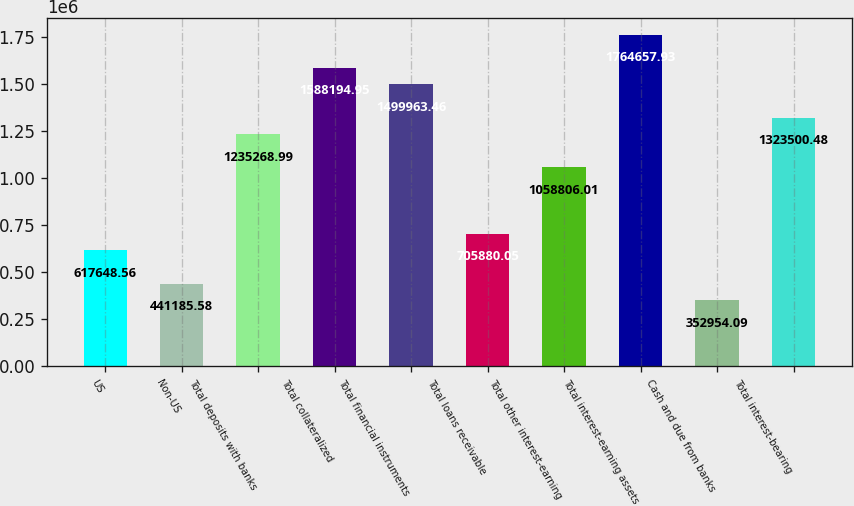Convert chart. <chart><loc_0><loc_0><loc_500><loc_500><bar_chart><fcel>US<fcel>Non-US<fcel>Total deposits with banks<fcel>Total collateralized<fcel>Total financial instruments<fcel>Total loans receivable<fcel>Total other interest-earning<fcel>Total interest-earning assets<fcel>Cash and due from banks<fcel>Total interest-bearing<nl><fcel>617649<fcel>441186<fcel>1.23527e+06<fcel>1.58819e+06<fcel>1.49996e+06<fcel>705880<fcel>1.05881e+06<fcel>1.76466e+06<fcel>352954<fcel>1.3235e+06<nl></chart> 